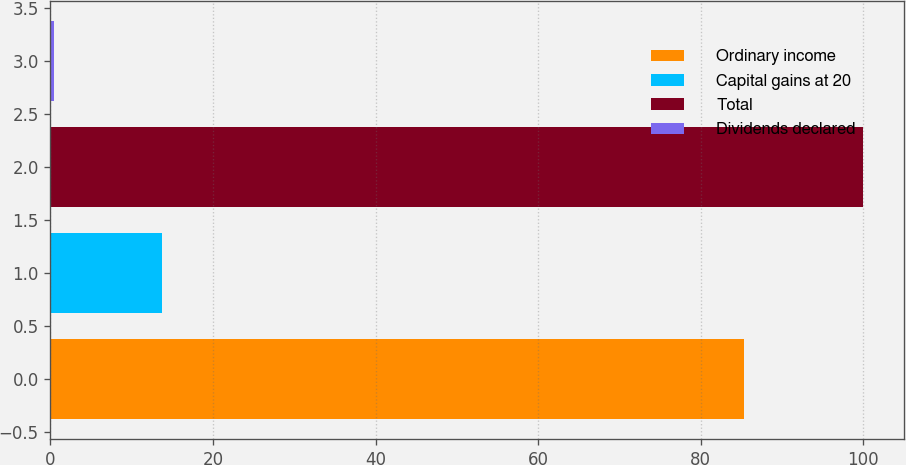<chart> <loc_0><loc_0><loc_500><loc_500><bar_chart><fcel>Ordinary income<fcel>Capital gains at 20<fcel>Total<fcel>Dividends declared<nl><fcel>85.3<fcel>13.7<fcel>100<fcel>0.4<nl></chart> 